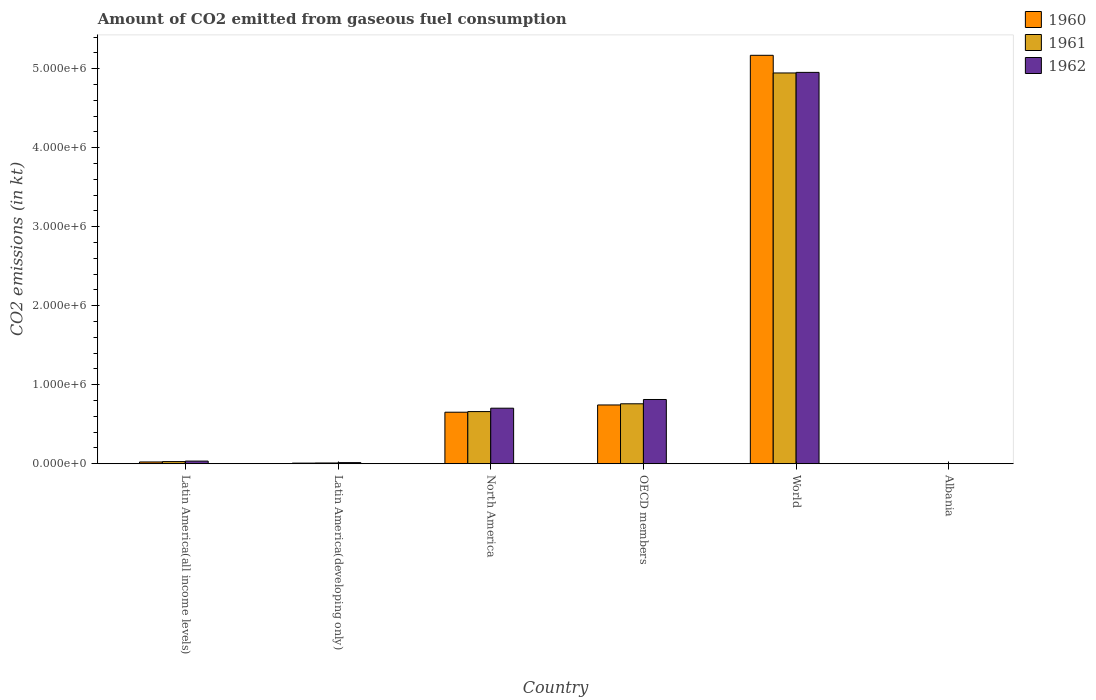How many different coloured bars are there?
Keep it short and to the point. 3. How many groups of bars are there?
Your response must be concise. 6. Are the number of bars on each tick of the X-axis equal?
Provide a short and direct response. Yes. In how many cases, is the number of bars for a given country not equal to the number of legend labels?
Give a very brief answer. 0. What is the amount of CO2 emitted in 1961 in World?
Your answer should be very brief. 4.95e+06. Across all countries, what is the maximum amount of CO2 emitted in 1962?
Your answer should be compact. 4.95e+06. Across all countries, what is the minimum amount of CO2 emitted in 1960?
Give a very brief answer. 84.34. In which country was the amount of CO2 emitted in 1961 maximum?
Provide a succinct answer. World. In which country was the amount of CO2 emitted in 1961 minimum?
Offer a terse response. Albania. What is the total amount of CO2 emitted in 1961 in the graph?
Your answer should be compact. 6.40e+06. What is the difference between the amount of CO2 emitted in 1961 in Latin America(developing only) and that in OECD members?
Keep it short and to the point. -7.49e+05. What is the difference between the amount of CO2 emitted in 1960 in OECD members and the amount of CO2 emitted in 1962 in Latin America(all income levels)?
Make the answer very short. 7.11e+05. What is the average amount of CO2 emitted in 1961 per country?
Offer a very short reply. 1.07e+06. What is the difference between the amount of CO2 emitted of/in 1961 and amount of CO2 emitted of/in 1960 in Latin America(developing only)?
Offer a terse response. 1876.23. In how many countries, is the amount of CO2 emitted in 1962 greater than 1800000 kt?
Your answer should be very brief. 1. What is the ratio of the amount of CO2 emitted in 1961 in OECD members to that in World?
Keep it short and to the point. 0.15. Is the difference between the amount of CO2 emitted in 1961 in Latin America(developing only) and World greater than the difference between the amount of CO2 emitted in 1960 in Latin America(developing only) and World?
Make the answer very short. Yes. What is the difference between the highest and the second highest amount of CO2 emitted in 1962?
Provide a short and direct response. 4.14e+06. What is the difference between the highest and the lowest amount of CO2 emitted in 1961?
Offer a terse response. 4.95e+06. In how many countries, is the amount of CO2 emitted in 1962 greater than the average amount of CO2 emitted in 1962 taken over all countries?
Give a very brief answer. 1. How many bars are there?
Offer a very short reply. 18. Are all the bars in the graph horizontal?
Ensure brevity in your answer.  No. Does the graph contain any zero values?
Keep it short and to the point. No. How many legend labels are there?
Give a very brief answer. 3. How are the legend labels stacked?
Make the answer very short. Vertical. What is the title of the graph?
Your answer should be very brief. Amount of CO2 emitted from gaseous fuel consumption. Does "2015" appear as one of the legend labels in the graph?
Ensure brevity in your answer.  No. What is the label or title of the X-axis?
Your answer should be compact. Country. What is the label or title of the Y-axis?
Provide a succinct answer. CO2 emissions (in kt). What is the CO2 emissions (in kt) in 1960 in Latin America(all income levels)?
Ensure brevity in your answer.  2.26e+04. What is the CO2 emissions (in kt) of 1961 in Latin America(all income levels)?
Your answer should be compact. 2.71e+04. What is the CO2 emissions (in kt) in 1962 in Latin America(all income levels)?
Provide a succinct answer. 3.35e+04. What is the CO2 emissions (in kt) in 1960 in Latin America(developing only)?
Offer a very short reply. 7838.55. What is the CO2 emissions (in kt) of 1961 in Latin America(developing only)?
Make the answer very short. 9714.77. What is the CO2 emissions (in kt) in 1962 in Latin America(developing only)?
Offer a very short reply. 1.42e+04. What is the CO2 emissions (in kt) of 1960 in North America?
Your response must be concise. 6.52e+05. What is the CO2 emissions (in kt) of 1961 in North America?
Give a very brief answer. 6.60e+05. What is the CO2 emissions (in kt) of 1962 in North America?
Your answer should be compact. 7.03e+05. What is the CO2 emissions (in kt) of 1960 in OECD members?
Ensure brevity in your answer.  7.44e+05. What is the CO2 emissions (in kt) in 1961 in OECD members?
Provide a succinct answer. 7.59e+05. What is the CO2 emissions (in kt) of 1962 in OECD members?
Keep it short and to the point. 8.13e+05. What is the CO2 emissions (in kt) in 1960 in World?
Make the answer very short. 5.17e+06. What is the CO2 emissions (in kt) in 1961 in World?
Make the answer very short. 4.95e+06. What is the CO2 emissions (in kt) of 1962 in World?
Your answer should be compact. 4.95e+06. What is the CO2 emissions (in kt) of 1960 in Albania?
Offer a terse response. 84.34. What is the CO2 emissions (in kt) in 1961 in Albania?
Make the answer very short. 84.34. What is the CO2 emissions (in kt) in 1962 in Albania?
Give a very brief answer. 84.34. Across all countries, what is the maximum CO2 emissions (in kt) of 1960?
Provide a succinct answer. 5.17e+06. Across all countries, what is the maximum CO2 emissions (in kt) of 1961?
Keep it short and to the point. 4.95e+06. Across all countries, what is the maximum CO2 emissions (in kt) of 1962?
Make the answer very short. 4.95e+06. Across all countries, what is the minimum CO2 emissions (in kt) of 1960?
Give a very brief answer. 84.34. Across all countries, what is the minimum CO2 emissions (in kt) of 1961?
Offer a terse response. 84.34. Across all countries, what is the minimum CO2 emissions (in kt) in 1962?
Give a very brief answer. 84.34. What is the total CO2 emissions (in kt) in 1960 in the graph?
Give a very brief answer. 6.60e+06. What is the total CO2 emissions (in kt) of 1961 in the graph?
Your answer should be very brief. 6.40e+06. What is the total CO2 emissions (in kt) in 1962 in the graph?
Make the answer very short. 6.52e+06. What is the difference between the CO2 emissions (in kt) of 1960 in Latin America(all income levels) and that in Latin America(developing only)?
Keep it short and to the point. 1.47e+04. What is the difference between the CO2 emissions (in kt) of 1961 in Latin America(all income levels) and that in Latin America(developing only)?
Keep it short and to the point. 1.74e+04. What is the difference between the CO2 emissions (in kt) of 1962 in Latin America(all income levels) and that in Latin America(developing only)?
Provide a short and direct response. 1.93e+04. What is the difference between the CO2 emissions (in kt) of 1960 in Latin America(all income levels) and that in North America?
Make the answer very short. -6.30e+05. What is the difference between the CO2 emissions (in kt) in 1961 in Latin America(all income levels) and that in North America?
Provide a succinct answer. -6.33e+05. What is the difference between the CO2 emissions (in kt) in 1962 in Latin America(all income levels) and that in North America?
Your answer should be very brief. -6.70e+05. What is the difference between the CO2 emissions (in kt) of 1960 in Latin America(all income levels) and that in OECD members?
Your response must be concise. -7.21e+05. What is the difference between the CO2 emissions (in kt) of 1961 in Latin America(all income levels) and that in OECD members?
Give a very brief answer. -7.32e+05. What is the difference between the CO2 emissions (in kt) of 1962 in Latin America(all income levels) and that in OECD members?
Provide a succinct answer. -7.80e+05. What is the difference between the CO2 emissions (in kt) in 1960 in Latin America(all income levels) and that in World?
Give a very brief answer. -5.15e+06. What is the difference between the CO2 emissions (in kt) of 1961 in Latin America(all income levels) and that in World?
Give a very brief answer. -4.92e+06. What is the difference between the CO2 emissions (in kt) of 1962 in Latin America(all income levels) and that in World?
Give a very brief answer. -4.92e+06. What is the difference between the CO2 emissions (in kt) of 1960 in Latin America(all income levels) and that in Albania?
Offer a very short reply. 2.25e+04. What is the difference between the CO2 emissions (in kt) in 1961 in Latin America(all income levels) and that in Albania?
Offer a very short reply. 2.70e+04. What is the difference between the CO2 emissions (in kt) of 1962 in Latin America(all income levels) and that in Albania?
Keep it short and to the point. 3.34e+04. What is the difference between the CO2 emissions (in kt) of 1960 in Latin America(developing only) and that in North America?
Your answer should be very brief. -6.45e+05. What is the difference between the CO2 emissions (in kt) of 1961 in Latin America(developing only) and that in North America?
Make the answer very short. -6.50e+05. What is the difference between the CO2 emissions (in kt) of 1962 in Latin America(developing only) and that in North America?
Give a very brief answer. -6.89e+05. What is the difference between the CO2 emissions (in kt) of 1960 in Latin America(developing only) and that in OECD members?
Your response must be concise. -7.36e+05. What is the difference between the CO2 emissions (in kt) in 1961 in Latin America(developing only) and that in OECD members?
Your answer should be very brief. -7.49e+05. What is the difference between the CO2 emissions (in kt) of 1962 in Latin America(developing only) and that in OECD members?
Keep it short and to the point. -7.99e+05. What is the difference between the CO2 emissions (in kt) in 1960 in Latin America(developing only) and that in World?
Ensure brevity in your answer.  -5.16e+06. What is the difference between the CO2 emissions (in kt) of 1961 in Latin America(developing only) and that in World?
Keep it short and to the point. -4.94e+06. What is the difference between the CO2 emissions (in kt) of 1962 in Latin America(developing only) and that in World?
Offer a very short reply. -4.94e+06. What is the difference between the CO2 emissions (in kt) of 1960 in Latin America(developing only) and that in Albania?
Provide a succinct answer. 7754.21. What is the difference between the CO2 emissions (in kt) of 1961 in Latin America(developing only) and that in Albania?
Ensure brevity in your answer.  9630.43. What is the difference between the CO2 emissions (in kt) in 1962 in Latin America(developing only) and that in Albania?
Ensure brevity in your answer.  1.41e+04. What is the difference between the CO2 emissions (in kt) of 1960 in North America and that in OECD members?
Offer a terse response. -9.17e+04. What is the difference between the CO2 emissions (in kt) of 1961 in North America and that in OECD members?
Offer a very short reply. -9.86e+04. What is the difference between the CO2 emissions (in kt) in 1962 in North America and that in OECD members?
Your answer should be compact. -1.10e+05. What is the difference between the CO2 emissions (in kt) in 1960 in North America and that in World?
Provide a succinct answer. -4.52e+06. What is the difference between the CO2 emissions (in kt) of 1961 in North America and that in World?
Give a very brief answer. -4.29e+06. What is the difference between the CO2 emissions (in kt) in 1962 in North America and that in World?
Give a very brief answer. -4.25e+06. What is the difference between the CO2 emissions (in kt) of 1960 in North America and that in Albania?
Ensure brevity in your answer.  6.52e+05. What is the difference between the CO2 emissions (in kt) in 1961 in North America and that in Albania?
Offer a very short reply. 6.60e+05. What is the difference between the CO2 emissions (in kt) of 1962 in North America and that in Albania?
Keep it short and to the point. 7.03e+05. What is the difference between the CO2 emissions (in kt) of 1960 in OECD members and that in World?
Your response must be concise. -4.43e+06. What is the difference between the CO2 emissions (in kt) in 1961 in OECD members and that in World?
Your response must be concise. -4.19e+06. What is the difference between the CO2 emissions (in kt) of 1962 in OECD members and that in World?
Give a very brief answer. -4.14e+06. What is the difference between the CO2 emissions (in kt) in 1960 in OECD members and that in Albania?
Provide a succinct answer. 7.44e+05. What is the difference between the CO2 emissions (in kt) of 1961 in OECD members and that in Albania?
Ensure brevity in your answer.  7.59e+05. What is the difference between the CO2 emissions (in kt) of 1962 in OECD members and that in Albania?
Give a very brief answer. 8.13e+05. What is the difference between the CO2 emissions (in kt) in 1960 in World and that in Albania?
Offer a terse response. 5.17e+06. What is the difference between the CO2 emissions (in kt) of 1961 in World and that in Albania?
Offer a terse response. 4.95e+06. What is the difference between the CO2 emissions (in kt) of 1962 in World and that in Albania?
Ensure brevity in your answer.  4.95e+06. What is the difference between the CO2 emissions (in kt) of 1960 in Latin America(all income levels) and the CO2 emissions (in kt) of 1961 in Latin America(developing only)?
Offer a very short reply. 1.29e+04. What is the difference between the CO2 emissions (in kt) of 1960 in Latin America(all income levels) and the CO2 emissions (in kt) of 1962 in Latin America(developing only)?
Make the answer very short. 8397.37. What is the difference between the CO2 emissions (in kt) of 1961 in Latin America(all income levels) and the CO2 emissions (in kt) of 1962 in Latin America(developing only)?
Ensure brevity in your answer.  1.29e+04. What is the difference between the CO2 emissions (in kt) in 1960 in Latin America(all income levels) and the CO2 emissions (in kt) in 1961 in North America?
Keep it short and to the point. -6.38e+05. What is the difference between the CO2 emissions (in kt) in 1960 in Latin America(all income levels) and the CO2 emissions (in kt) in 1962 in North America?
Offer a very short reply. -6.81e+05. What is the difference between the CO2 emissions (in kt) in 1961 in Latin America(all income levels) and the CO2 emissions (in kt) in 1962 in North America?
Provide a succinct answer. -6.76e+05. What is the difference between the CO2 emissions (in kt) in 1960 in Latin America(all income levels) and the CO2 emissions (in kt) in 1961 in OECD members?
Keep it short and to the point. -7.36e+05. What is the difference between the CO2 emissions (in kt) of 1960 in Latin America(all income levels) and the CO2 emissions (in kt) of 1962 in OECD members?
Offer a terse response. -7.91e+05. What is the difference between the CO2 emissions (in kt) in 1961 in Latin America(all income levels) and the CO2 emissions (in kt) in 1962 in OECD members?
Give a very brief answer. -7.86e+05. What is the difference between the CO2 emissions (in kt) in 1960 in Latin America(all income levels) and the CO2 emissions (in kt) in 1961 in World?
Provide a short and direct response. -4.92e+06. What is the difference between the CO2 emissions (in kt) in 1960 in Latin America(all income levels) and the CO2 emissions (in kt) in 1962 in World?
Offer a very short reply. -4.93e+06. What is the difference between the CO2 emissions (in kt) of 1961 in Latin America(all income levels) and the CO2 emissions (in kt) of 1962 in World?
Your response must be concise. -4.93e+06. What is the difference between the CO2 emissions (in kt) in 1960 in Latin America(all income levels) and the CO2 emissions (in kt) in 1961 in Albania?
Offer a terse response. 2.25e+04. What is the difference between the CO2 emissions (in kt) of 1960 in Latin America(all income levels) and the CO2 emissions (in kt) of 1962 in Albania?
Offer a very short reply. 2.25e+04. What is the difference between the CO2 emissions (in kt) in 1961 in Latin America(all income levels) and the CO2 emissions (in kt) in 1962 in Albania?
Your answer should be very brief. 2.70e+04. What is the difference between the CO2 emissions (in kt) of 1960 in Latin America(developing only) and the CO2 emissions (in kt) of 1961 in North America?
Offer a very short reply. -6.52e+05. What is the difference between the CO2 emissions (in kt) of 1960 in Latin America(developing only) and the CO2 emissions (in kt) of 1962 in North America?
Make the answer very short. -6.95e+05. What is the difference between the CO2 emissions (in kt) of 1961 in Latin America(developing only) and the CO2 emissions (in kt) of 1962 in North America?
Provide a succinct answer. -6.93e+05. What is the difference between the CO2 emissions (in kt) in 1960 in Latin America(developing only) and the CO2 emissions (in kt) in 1961 in OECD members?
Your response must be concise. -7.51e+05. What is the difference between the CO2 emissions (in kt) in 1960 in Latin America(developing only) and the CO2 emissions (in kt) in 1962 in OECD members?
Make the answer very short. -8.05e+05. What is the difference between the CO2 emissions (in kt) in 1961 in Latin America(developing only) and the CO2 emissions (in kt) in 1962 in OECD members?
Keep it short and to the point. -8.03e+05. What is the difference between the CO2 emissions (in kt) in 1960 in Latin America(developing only) and the CO2 emissions (in kt) in 1961 in World?
Your answer should be compact. -4.94e+06. What is the difference between the CO2 emissions (in kt) in 1960 in Latin America(developing only) and the CO2 emissions (in kt) in 1962 in World?
Keep it short and to the point. -4.95e+06. What is the difference between the CO2 emissions (in kt) of 1961 in Latin America(developing only) and the CO2 emissions (in kt) of 1962 in World?
Your answer should be compact. -4.94e+06. What is the difference between the CO2 emissions (in kt) of 1960 in Latin America(developing only) and the CO2 emissions (in kt) of 1961 in Albania?
Give a very brief answer. 7754.21. What is the difference between the CO2 emissions (in kt) in 1960 in Latin America(developing only) and the CO2 emissions (in kt) in 1962 in Albania?
Offer a very short reply. 7754.21. What is the difference between the CO2 emissions (in kt) of 1961 in Latin America(developing only) and the CO2 emissions (in kt) of 1962 in Albania?
Your response must be concise. 9630.43. What is the difference between the CO2 emissions (in kt) of 1960 in North America and the CO2 emissions (in kt) of 1961 in OECD members?
Offer a very short reply. -1.06e+05. What is the difference between the CO2 emissions (in kt) of 1960 in North America and the CO2 emissions (in kt) of 1962 in OECD members?
Your answer should be very brief. -1.61e+05. What is the difference between the CO2 emissions (in kt) of 1961 in North America and the CO2 emissions (in kt) of 1962 in OECD members?
Offer a terse response. -1.53e+05. What is the difference between the CO2 emissions (in kt) of 1960 in North America and the CO2 emissions (in kt) of 1961 in World?
Provide a short and direct response. -4.29e+06. What is the difference between the CO2 emissions (in kt) in 1960 in North America and the CO2 emissions (in kt) in 1962 in World?
Offer a terse response. -4.30e+06. What is the difference between the CO2 emissions (in kt) in 1961 in North America and the CO2 emissions (in kt) in 1962 in World?
Keep it short and to the point. -4.29e+06. What is the difference between the CO2 emissions (in kt) in 1960 in North America and the CO2 emissions (in kt) in 1961 in Albania?
Your answer should be compact. 6.52e+05. What is the difference between the CO2 emissions (in kt) of 1960 in North America and the CO2 emissions (in kt) of 1962 in Albania?
Your answer should be compact. 6.52e+05. What is the difference between the CO2 emissions (in kt) of 1961 in North America and the CO2 emissions (in kt) of 1962 in Albania?
Provide a short and direct response. 6.60e+05. What is the difference between the CO2 emissions (in kt) in 1960 in OECD members and the CO2 emissions (in kt) in 1961 in World?
Offer a very short reply. -4.20e+06. What is the difference between the CO2 emissions (in kt) of 1960 in OECD members and the CO2 emissions (in kt) of 1962 in World?
Make the answer very short. -4.21e+06. What is the difference between the CO2 emissions (in kt) of 1961 in OECD members and the CO2 emissions (in kt) of 1962 in World?
Make the answer very short. -4.20e+06. What is the difference between the CO2 emissions (in kt) of 1960 in OECD members and the CO2 emissions (in kt) of 1961 in Albania?
Ensure brevity in your answer.  7.44e+05. What is the difference between the CO2 emissions (in kt) in 1960 in OECD members and the CO2 emissions (in kt) in 1962 in Albania?
Keep it short and to the point. 7.44e+05. What is the difference between the CO2 emissions (in kt) in 1961 in OECD members and the CO2 emissions (in kt) in 1962 in Albania?
Your response must be concise. 7.59e+05. What is the difference between the CO2 emissions (in kt) in 1960 in World and the CO2 emissions (in kt) in 1961 in Albania?
Give a very brief answer. 5.17e+06. What is the difference between the CO2 emissions (in kt) of 1960 in World and the CO2 emissions (in kt) of 1962 in Albania?
Give a very brief answer. 5.17e+06. What is the difference between the CO2 emissions (in kt) of 1961 in World and the CO2 emissions (in kt) of 1962 in Albania?
Offer a terse response. 4.95e+06. What is the average CO2 emissions (in kt) in 1960 per country?
Offer a very short reply. 1.10e+06. What is the average CO2 emissions (in kt) in 1961 per country?
Your response must be concise. 1.07e+06. What is the average CO2 emissions (in kt) of 1962 per country?
Offer a terse response. 1.09e+06. What is the difference between the CO2 emissions (in kt) of 1960 and CO2 emissions (in kt) of 1961 in Latin America(all income levels)?
Provide a short and direct response. -4542.92. What is the difference between the CO2 emissions (in kt) in 1960 and CO2 emissions (in kt) in 1962 in Latin America(all income levels)?
Offer a terse response. -1.09e+04. What is the difference between the CO2 emissions (in kt) of 1961 and CO2 emissions (in kt) of 1962 in Latin America(all income levels)?
Offer a terse response. -6377.63. What is the difference between the CO2 emissions (in kt) in 1960 and CO2 emissions (in kt) in 1961 in Latin America(developing only)?
Ensure brevity in your answer.  -1876.23. What is the difference between the CO2 emissions (in kt) of 1960 and CO2 emissions (in kt) of 1962 in Latin America(developing only)?
Offer a very short reply. -6343.06. What is the difference between the CO2 emissions (in kt) of 1961 and CO2 emissions (in kt) of 1962 in Latin America(developing only)?
Your answer should be compact. -4466.83. What is the difference between the CO2 emissions (in kt) of 1960 and CO2 emissions (in kt) of 1961 in North America?
Offer a terse response. -7828.66. What is the difference between the CO2 emissions (in kt) of 1960 and CO2 emissions (in kt) of 1962 in North America?
Your answer should be very brief. -5.08e+04. What is the difference between the CO2 emissions (in kt) in 1961 and CO2 emissions (in kt) in 1962 in North America?
Make the answer very short. -4.30e+04. What is the difference between the CO2 emissions (in kt) of 1960 and CO2 emissions (in kt) of 1961 in OECD members?
Make the answer very short. -1.48e+04. What is the difference between the CO2 emissions (in kt) in 1960 and CO2 emissions (in kt) in 1962 in OECD members?
Your answer should be compact. -6.92e+04. What is the difference between the CO2 emissions (in kt) in 1961 and CO2 emissions (in kt) in 1962 in OECD members?
Provide a short and direct response. -5.44e+04. What is the difference between the CO2 emissions (in kt) of 1960 and CO2 emissions (in kt) of 1961 in World?
Ensure brevity in your answer.  2.24e+05. What is the difference between the CO2 emissions (in kt) in 1960 and CO2 emissions (in kt) in 1962 in World?
Provide a succinct answer. 2.16e+05. What is the difference between the CO2 emissions (in kt) in 1961 and CO2 emissions (in kt) in 1962 in World?
Your answer should be compact. -7334. What is the difference between the CO2 emissions (in kt) of 1961 and CO2 emissions (in kt) of 1962 in Albania?
Make the answer very short. 0. What is the ratio of the CO2 emissions (in kt) in 1960 in Latin America(all income levels) to that in Latin America(developing only)?
Offer a very short reply. 2.88. What is the ratio of the CO2 emissions (in kt) of 1961 in Latin America(all income levels) to that in Latin America(developing only)?
Your response must be concise. 2.79. What is the ratio of the CO2 emissions (in kt) in 1962 in Latin America(all income levels) to that in Latin America(developing only)?
Provide a short and direct response. 2.36. What is the ratio of the CO2 emissions (in kt) in 1960 in Latin America(all income levels) to that in North America?
Offer a very short reply. 0.03. What is the ratio of the CO2 emissions (in kt) in 1961 in Latin America(all income levels) to that in North America?
Your answer should be very brief. 0.04. What is the ratio of the CO2 emissions (in kt) of 1962 in Latin America(all income levels) to that in North America?
Give a very brief answer. 0.05. What is the ratio of the CO2 emissions (in kt) in 1960 in Latin America(all income levels) to that in OECD members?
Keep it short and to the point. 0.03. What is the ratio of the CO2 emissions (in kt) in 1961 in Latin America(all income levels) to that in OECD members?
Keep it short and to the point. 0.04. What is the ratio of the CO2 emissions (in kt) in 1962 in Latin America(all income levels) to that in OECD members?
Your answer should be very brief. 0.04. What is the ratio of the CO2 emissions (in kt) in 1960 in Latin America(all income levels) to that in World?
Ensure brevity in your answer.  0. What is the ratio of the CO2 emissions (in kt) of 1961 in Latin America(all income levels) to that in World?
Keep it short and to the point. 0.01. What is the ratio of the CO2 emissions (in kt) of 1962 in Latin America(all income levels) to that in World?
Your answer should be compact. 0.01. What is the ratio of the CO2 emissions (in kt) in 1960 in Latin America(all income levels) to that in Albania?
Your response must be concise. 267.71. What is the ratio of the CO2 emissions (in kt) of 1961 in Latin America(all income levels) to that in Albania?
Your response must be concise. 321.57. What is the ratio of the CO2 emissions (in kt) in 1962 in Latin America(all income levels) to that in Albania?
Keep it short and to the point. 397.19. What is the ratio of the CO2 emissions (in kt) of 1960 in Latin America(developing only) to that in North America?
Offer a very short reply. 0.01. What is the ratio of the CO2 emissions (in kt) in 1961 in Latin America(developing only) to that in North America?
Keep it short and to the point. 0.01. What is the ratio of the CO2 emissions (in kt) of 1962 in Latin America(developing only) to that in North America?
Keep it short and to the point. 0.02. What is the ratio of the CO2 emissions (in kt) of 1960 in Latin America(developing only) to that in OECD members?
Provide a short and direct response. 0.01. What is the ratio of the CO2 emissions (in kt) in 1961 in Latin America(developing only) to that in OECD members?
Provide a short and direct response. 0.01. What is the ratio of the CO2 emissions (in kt) of 1962 in Latin America(developing only) to that in OECD members?
Your answer should be very brief. 0.02. What is the ratio of the CO2 emissions (in kt) in 1960 in Latin America(developing only) to that in World?
Keep it short and to the point. 0. What is the ratio of the CO2 emissions (in kt) of 1961 in Latin America(developing only) to that in World?
Offer a very short reply. 0. What is the ratio of the CO2 emissions (in kt) of 1962 in Latin America(developing only) to that in World?
Provide a succinct answer. 0. What is the ratio of the CO2 emissions (in kt) of 1960 in Latin America(developing only) to that in Albania?
Offer a very short reply. 92.94. What is the ratio of the CO2 emissions (in kt) in 1961 in Latin America(developing only) to that in Albania?
Give a very brief answer. 115.18. What is the ratio of the CO2 emissions (in kt) in 1962 in Latin America(developing only) to that in Albania?
Offer a very short reply. 168.15. What is the ratio of the CO2 emissions (in kt) in 1960 in North America to that in OECD members?
Provide a succinct answer. 0.88. What is the ratio of the CO2 emissions (in kt) of 1961 in North America to that in OECD members?
Offer a terse response. 0.87. What is the ratio of the CO2 emissions (in kt) of 1962 in North America to that in OECD members?
Provide a succinct answer. 0.86. What is the ratio of the CO2 emissions (in kt) of 1960 in North America to that in World?
Your answer should be very brief. 0.13. What is the ratio of the CO2 emissions (in kt) of 1961 in North America to that in World?
Offer a very short reply. 0.13. What is the ratio of the CO2 emissions (in kt) of 1962 in North America to that in World?
Keep it short and to the point. 0.14. What is the ratio of the CO2 emissions (in kt) of 1960 in North America to that in Albania?
Ensure brevity in your answer.  7734.89. What is the ratio of the CO2 emissions (in kt) in 1961 in North America to that in Albania?
Your response must be concise. 7827.72. What is the ratio of the CO2 emissions (in kt) of 1962 in North America to that in Albania?
Your response must be concise. 8337.76. What is the ratio of the CO2 emissions (in kt) of 1960 in OECD members to that in World?
Ensure brevity in your answer.  0.14. What is the ratio of the CO2 emissions (in kt) in 1961 in OECD members to that in World?
Keep it short and to the point. 0.15. What is the ratio of the CO2 emissions (in kt) in 1962 in OECD members to that in World?
Your response must be concise. 0.16. What is the ratio of the CO2 emissions (in kt) in 1960 in OECD members to that in Albania?
Offer a terse response. 8821.78. What is the ratio of the CO2 emissions (in kt) of 1961 in OECD members to that in Albania?
Provide a succinct answer. 8997.23. What is the ratio of the CO2 emissions (in kt) in 1962 in OECD members to that in Albania?
Offer a terse response. 9641.88. What is the ratio of the CO2 emissions (in kt) of 1960 in World to that in Albania?
Your answer should be compact. 6.13e+04. What is the ratio of the CO2 emissions (in kt) in 1961 in World to that in Albania?
Your response must be concise. 5.87e+04. What is the ratio of the CO2 emissions (in kt) of 1962 in World to that in Albania?
Keep it short and to the point. 5.87e+04. What is the difference between the highest and the second highest CO2 emissions (in kt) in 1960?
Your answer should be compact. 4.43e+06. What is the difference between the highest and the second highest CO2 emissions (in kt) in 1961?
Keep it short and to the point. 4.19e+06. What is the difference between the highest and the second highest CO2 emissions (in kt) of 1962?
Offer a terse response. 4.14e+06. What is the difference between the highest and the lowest CO2 emissions (in kt) of 1960?
Your response must be concise. 5.17e+06. What is the difference between the highest and the lowest CO2 emissions (in kt) of 1961?
Your answer should be compact. 4.95e+06. What is the difference between the highest and the lowest CO2 emissions (in kt) of 1962?
Keep it short and to the point. 4.95e+06. 